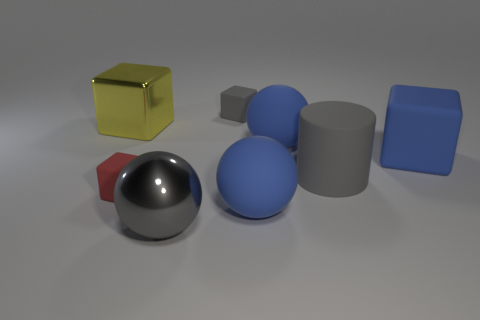Do the cylinder and the shiny ball have the same color?
Your response must be concise. Yes. Is the number of matte blocks that are behind the metallic cube greater than the number of tiny cyan matte cylinders?
Offer a terse response. Yes. There is a small rubber thing that is to the left of the big gray metallic ball; is it the same shape as the large yellow thing?
Your answer should be compact. Yes. Is there a blue object that has the same shape as the big gray metallic thing?
Provide a short and direct response. Yes. How many things are small rubber blocks in front of the big yellow shiny thing or small matte cubes?
Your answer should be compact. 2. Are there more green blocks than big balls?
Your response must be concise. No. Are there any gray objects of the same size as the red block?
Offer a very short reply. Yes. What number of objects are either tiny objects that are in front of the large cylinder or tiny rubber objects that are in front of the big yellow thing?
Your answer should be compact. 1. What is the color of the large block that is on the right side of the big yellow metal object that is left of the tiny gray rubber thing?
Ensure brevity in your answer.  Blue. There is a small thing that is made of the same material as the gray cube; what color is it?
Give a very brief answer. Red. 